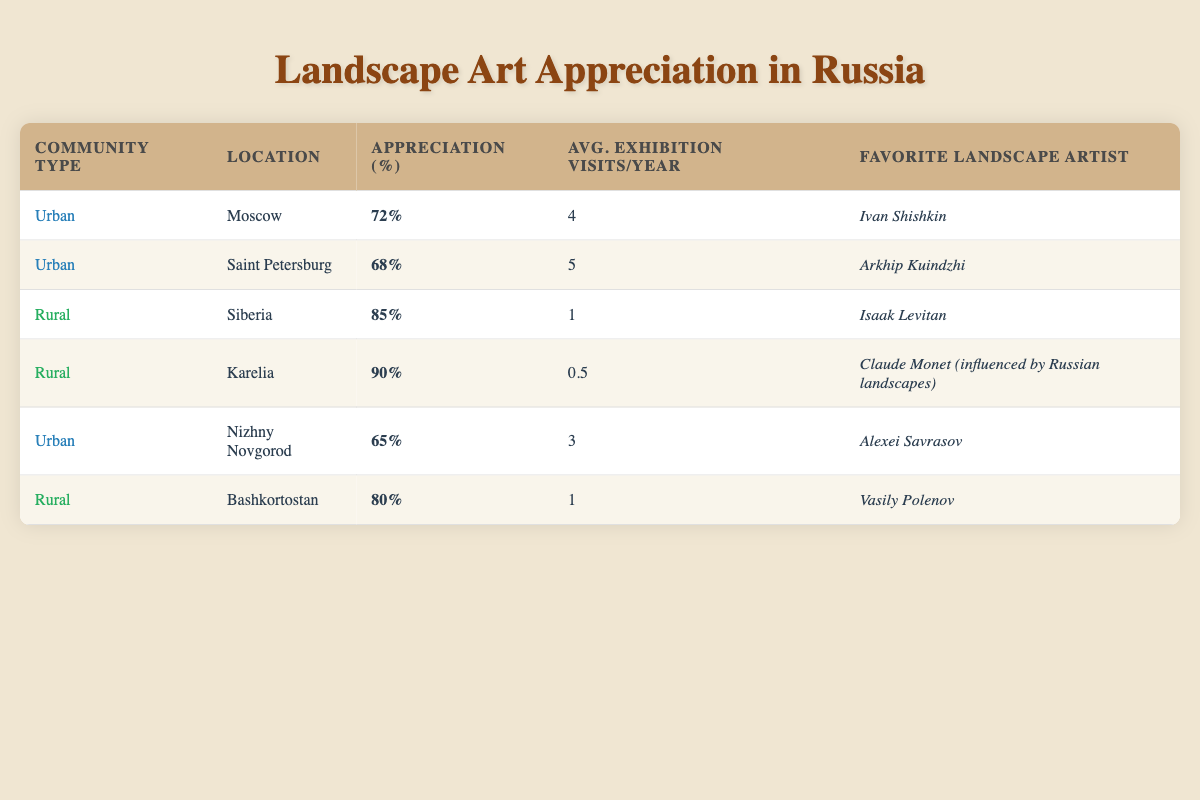What is the percentage appreciation of landscape art in Saint Petersburg? Looking at the table, the percentage appreciation for Saint Petersburg, which is listed under the Urban community type, is 68%.
Answer: 68% Which region has the highest appreciation for landscape art? The table shows that Karelia, a rural region, has the highest percentage appreciation at 90%.
Answer: Karelia What is the average number of exhibition visits per year in urban communities? The average for urban communities can be calculated by summing the average visits for Moscow, Saint Petersburg, and Nizhny Novgorod, which is (4 + 5 + 3) = 12. There are 3 urban data points, so the average is 12/3 = 4.
Answer: 4 Is the favorite landscape artist in Siberia different from the one in Bashkortostan? According to the table, the favorite artist in Siberia is Isaak Levitan, while in Bashkortostan, it is Vasily Polenov. Since these names are different, the answer is yes.
Answer: Yes What percentage appreciation do rural areas have on average compared to urban areas? First, we calculate the average appreciation for rural areas by adding the percentages for Siberia, Karelia, and Bashkortostan: (85 + 90 + 80) = 255, divided by 3 results in 85%. For urban areas, the average is (72 + 68 + 65) = 205, divided by 3 results in approximately 68.33%. So rural areas have notably higher appreciation on average.
Answer: 85% vs 68.33% 